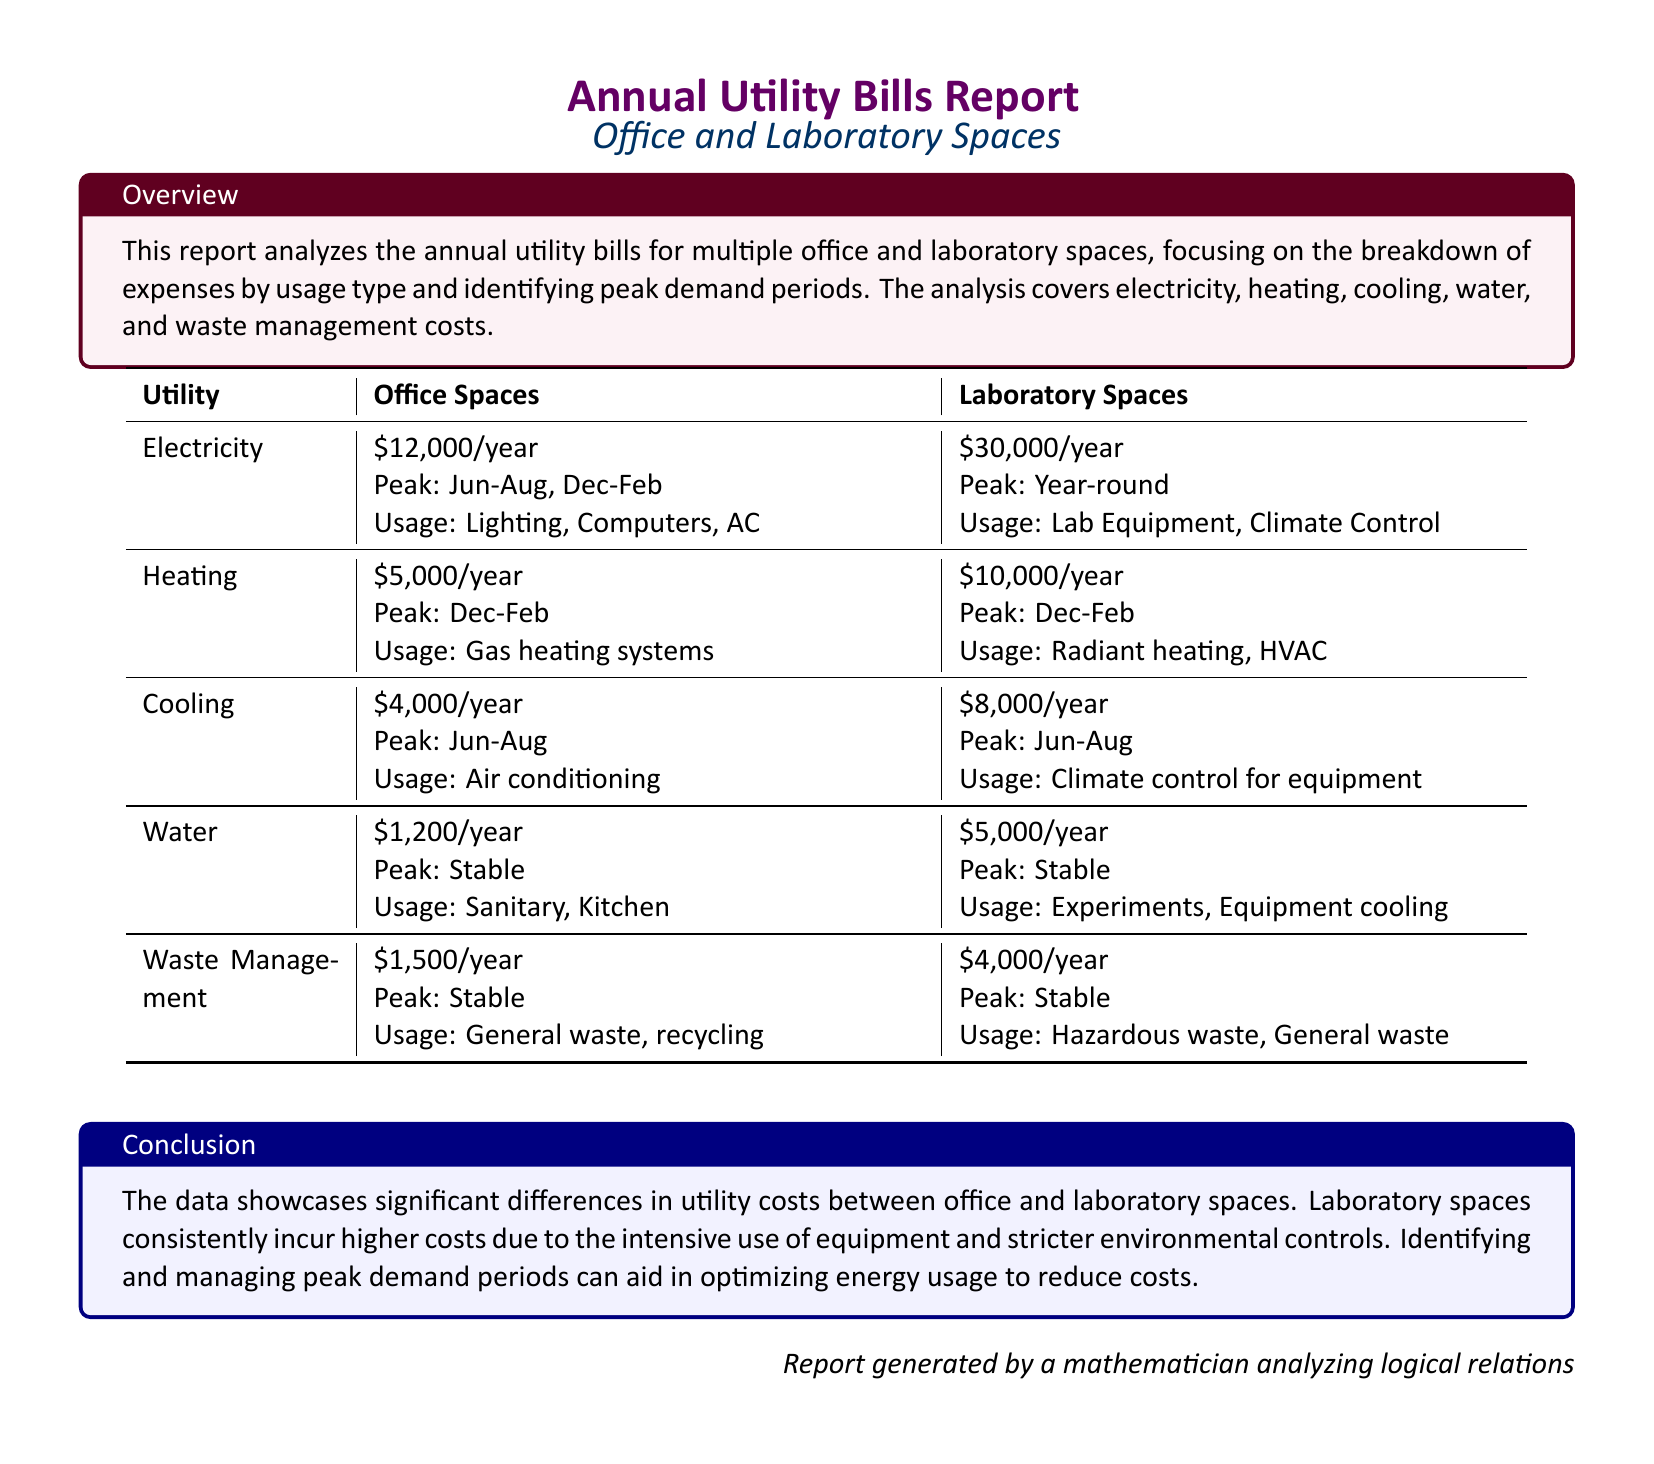What is the total annual electricity cost for office spaces? The total annual electricity cost for office spaces is mentioned in the document as $12,000/year.
Answer: $12,000/year Which utility has the highest expense for laboratory spaces? The expenses for each utility type in laboratory spaces indicate that electricity incurs the highest cost at $30,000/year.
Answer: $30,000/year What are the peak months for heating costs in both office and laboratory spaces? Both office and laboratory spaces have peak heating costs during the months of December to February.
Answer: Dec-Feb How much does water usage cost for office spaces annually? The document specifies that the annual water cost for office spaces is $1,200/year.
Answer: $1,200/year What is the total waste management cost for laboratory spaces? The total waste management cost for laboratory spaces is detailed as $4,000/year.
Answer: $4,000/year What types of equipment contribute to the peak electricity demand in laboratory spaces? The report states that lab equipment and climate control contribute to the peak electricity demand in laboratory spaces.
Answer: Lab Equipment, Climate Control Which utility type has stable peak periods for both office and laboratory spaces? The utility type that is stated to have stable peak periods for both office and laboratory spaces is water.
Answer: Water How does the total heating cost for office spaces compare to that of laboratory spaces? The total heating cost for office spaces is $5,000/year, while for laboratory spaces it is $10,000/year, indicating that laboratory spaces incur more costs.
Answer: $5,000/year vs $10,000/year What is the annual cost of cooling for laboratory spaces? The document details that the annual cooling cost for laboratory spaces is $8,000/year.
Answer: $8,000/year 